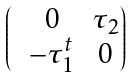<formula> <loc_0><loc_0><loc_500><loc_500>\begin{pmatrix} & 0 & { \tau } _ { 2 } \\ & - \tau _ { 1 } ^ { t } & 0 \end{pmatrix}</formula> 